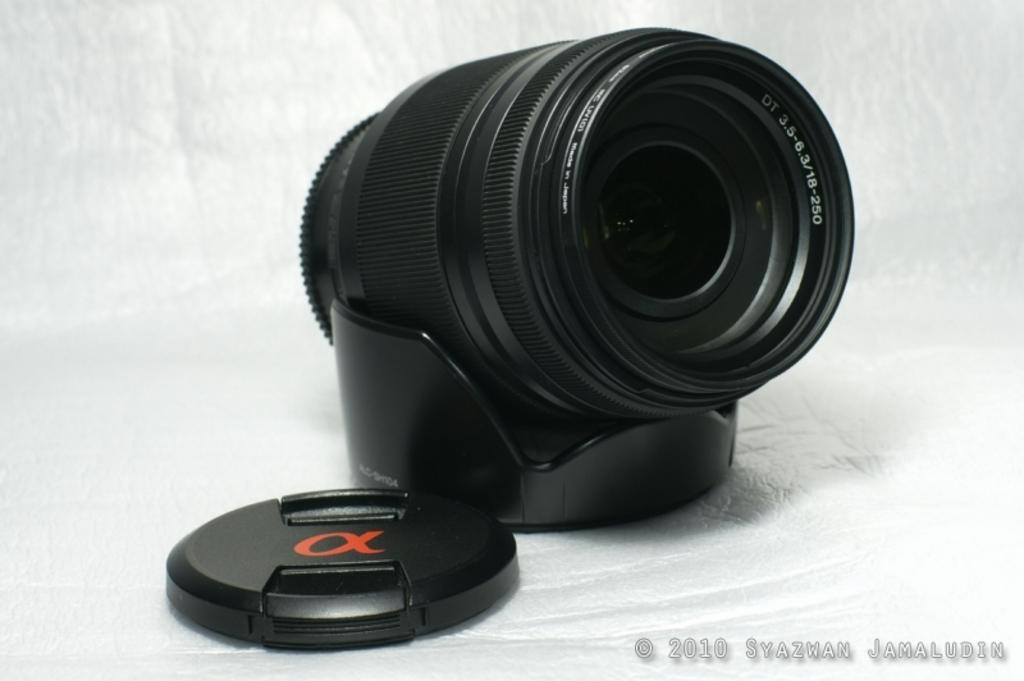What is the main object in the image? There is a black color lens in the image. How is the lens positioned in the image? The lens is placed on a black color stand. What other black color object can be seen in the image? There is a black color cup in the image. What is the color of the surface on which the objects are placed? The objects are on a white color surface. What is the color of the background in the image? The background of the image is white in color. How many copies of the lens are visible in the image? There is only one lens visible in the image, so there are no copies. What is the purpose of the afterthought in the image? There is no mention of an afterthought in the image, as the facts provided focus on the lens, stand, cup, and colors. 